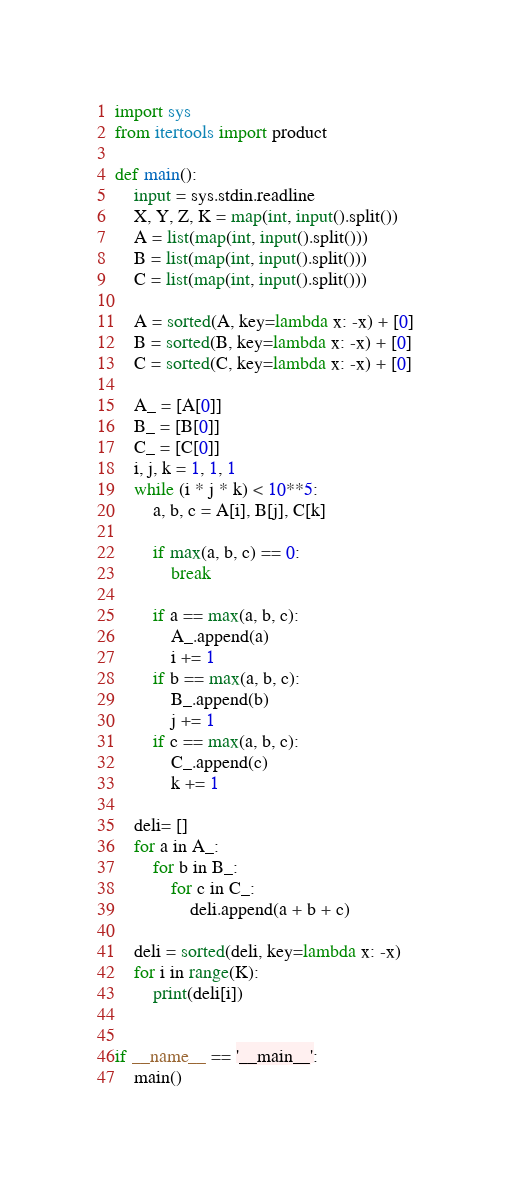Convert code to text. <code><loc_0><loc_0><loc_500><loc_500><_Python_>import sys
from itertools import product

def main():
    input = sys.stdin.readline
    X, Y, Z, K = map(int, input().split())
    A = list(map(int, input().split()))
    B = list(map(int, input().split()))
    C = list(map(int, input().split()))

    A = sorted(A, key=lambda x: -x) + [0]
    B = sorted(B, key=lambda x: -x) + [0]
    C = sorted(C, key=lambda x: -x) + [0]

    A_ = [A[0]]
    B_ = [B[0]]
    C_ = [C[0]]
    i, j, k = 1, 1, 1
    while (i * j * k) < 10**5:
        a, b, c = A[i], B[j], C[k]

        if max(a, b, c) == 0:
            break

        if a == max(a, b, c):
            A_.append(a)
            i += 1
        if b == max(a, b, c):
            B_.append(b)
            j += 1
        if c == max(a, b, c):
            C_.append(c)
            k += 1

    deli= []
    for a in A_:
        for b in B_:
            for c in C_:
                deli.append(a + b + c)

    deli = sorted(deli, key=lambda x: -x)
    for i in range(K):
        print(deli[i])


if __name__ == '__main__':
    main()
</code> 